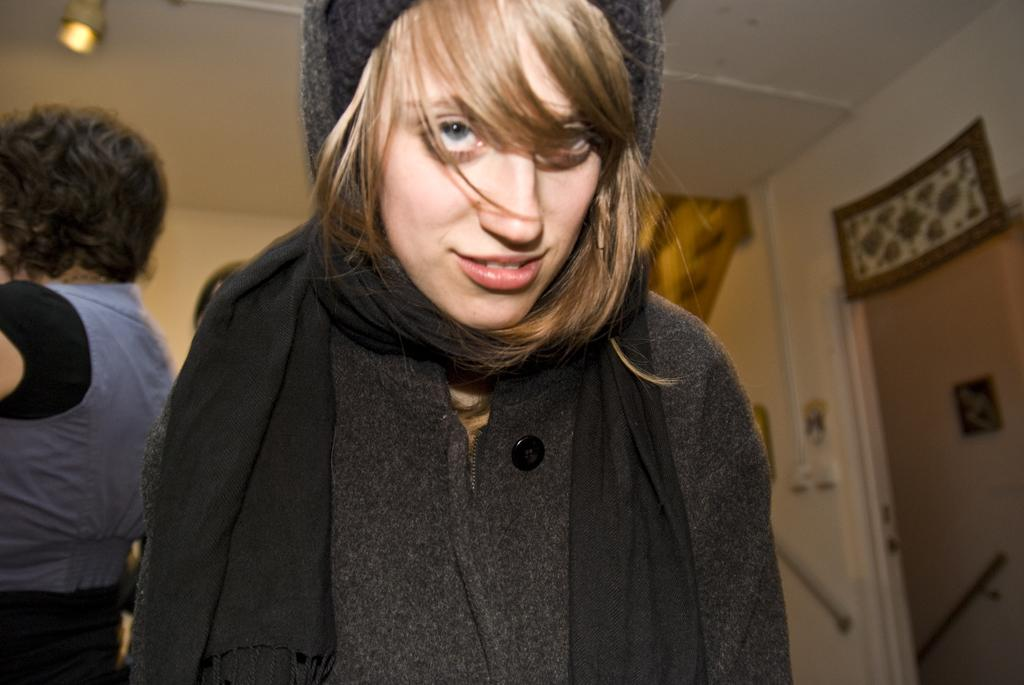Who is the main subject in the front of the image? There is a woman in the front of the image. What is the woman wearing? The woman is wearing a black dress. Can you describe the person on the left side of the image? There is another person on the left side of the image, but their appearance is not specified. What is the source of light in the image? There is a light at the top of the image. What is the door used for in the image? The door on the right side of the image is likely used for entering or exiting a room or building. How does the woman plan to take flight in the image? There is no indication in the image that the woman is planning to take flight or that any flight-related activities are taking place. 